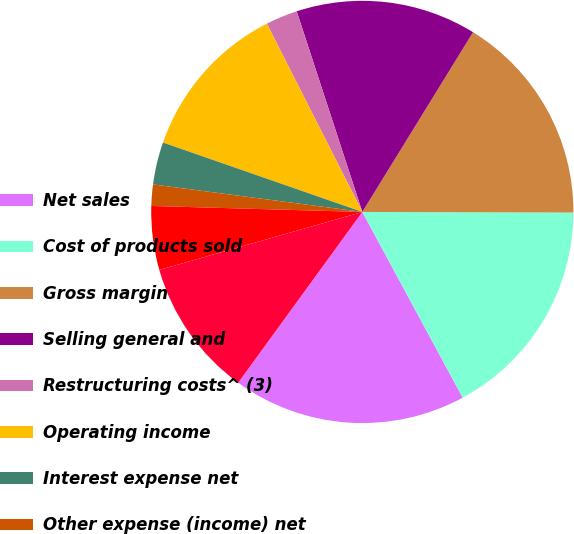Convert chart to OTSL. <chart><loc_0><loc_0><loc_500><loc_500><pie_chart><fcel>Net sales<fcel>Cost of products sold<fcel>Gross margin<fcel>Selling general and<fcel>Restructuring costs^ (3)<fcel>Operating income<fcel>Interest expense net<fcel>Other expense (income) net<fcel>Net nonoperating expenses<fcel>Income before income taxes<nl><fcel>17.89%<fcel>17.07%<fcel>16.26%<fcel>13.82%<fcel>2.44%<fcel>12.2%<fcel>3.25%<fcel>1.63%<fcel>4.88%<fcel>10.57%<nl></chart> 